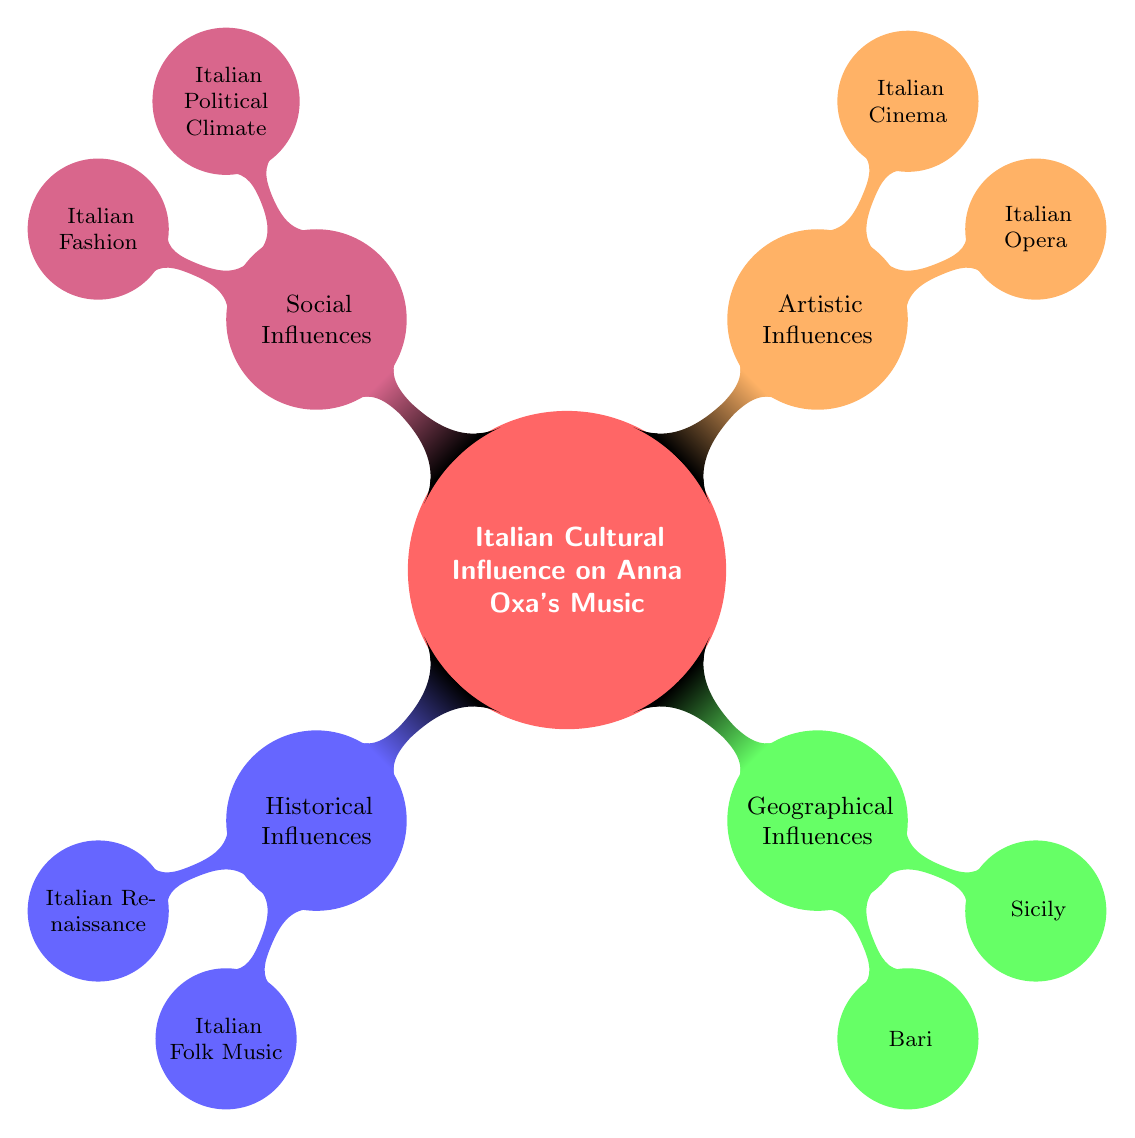What is the main theme of the mind map? The main theme is indicated at the center of the mind map, specifically highlighting "Italian Cultural Influence on Anna Oxa's Music." This acts as the focal point from which all other branches extend.
Answer: Italian Cultural Influence on Anna Oxa's Music How many main branches are there? Counting the branches extending from the central theme, there are four main branches: Historical Influences, Geographical Influences, Artistic Influences, and Social Influences.
Answer: 4 What type of music influences Anna Oxa's work according to the diagram? The diagram mentions "Italian Folk Music" specifically as a type of musical influence, showcasing the traditional aspect of her influences.
Answer: Italian Folk Music Which city is mentioned as a geographical influence? Among the geographical influences, "Bari" is specified as a significant location contributing to Anna Oxa's music, particularly reflecting her hometown's musical heritage.
Answer: Bari What artistic influence is linked to storytelling? "Italian Opera" is highlighted as an artistic influence that involves dramatic vocal techniques and storytelling aspects, indicating a deep connection to narrative forms in her music.
Answer: Italian Opera What influences are found under the Social Influences branch? Under the Social Influences branch, two elements are listed: "Italian Political Climate" and "Italian Fashion", pointing to the societal aspects that shape her music and public persona.
Answer: Italian Political Climate, Italian Fashion What aspect of Anna Oxa’s music is inspired by Sicily? The diagram identifies "Sicilian rhythms and folk traditions" as the specific influence coming from Sicily, thereby highlighting the regional musical richness reflected in her work.
Answer: Sicilian rhythms and folk traditions Which Italian director is referenced in the mind map? The mind map details "Italian Cinema" as an artistic influence and explicitly mentions "Fellini," connecting Anna Oxa's work to the legacy of notable Italian filmmakers.
Answer: Fellini Which historical period is mentioned as an influence? The "Italian Renaissance" is noted as a historical influence that contributes to the richness and classical themes present in Anna Oxa's music style and performances.
Answer: Italian Renaissance 